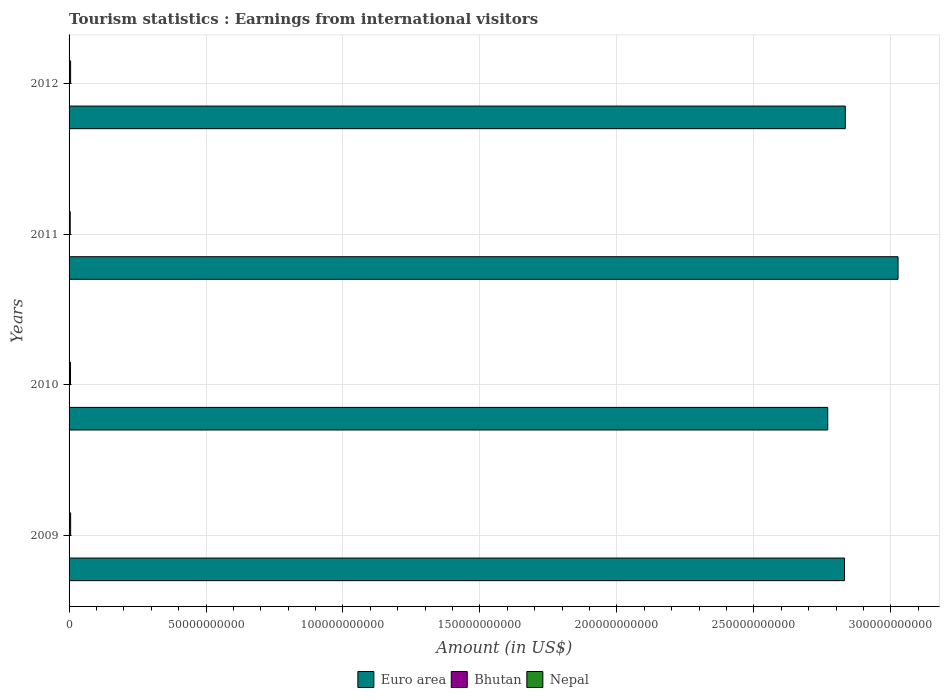How many groups of bars are there?
Keep it short and to the point. 4. Are the number of bars per tick equal to the number of legend labels?
Keep it short and to the point. Yes. Are the number of bars on each tick of the Y-axis equal?
Make the answer very short. Yes. How many bars are there on the 1st tick from the top?
Offer a very short reply. 3. How many bars are there on the 4th tick from the bottom?
Your answer should be compact. 3. What is the label of the 4th group of bars from the top?
Ensure brevity in your answer.  2009. What is the earnings from international visitors in Nepal in 2011?
Your answer should be compact. 4.20e+08. Across all years, what is the maximum earnings from international visitors in Bhutan?
Your answer should be very brief. 7.00e+07. Across all years, what is the minimum earnings from international visitors in Nepal?
Make the answer very short. 4.20e+08. In which year was the earnings from international visitors in Nepal maximum?
Offer a terse response. 2009. What is the total earnings from international visitors in Bhutan in the graph?
Ensure brevity in your answer.  2.05e+08. What is the difference between the earnings from international visitors in Euro area in 2009 and that in 2011?
Your answer should be compact. -1.95e+1. What is the difference between the earnings from international visitors in Euro area in 2010 and the earnings from international visitors in Bhutan in 2012?
Offer a very short reply. 2.77e+11. What is the average earnings from international visitors in Euro area per year?
Ensure brevity in your answer.  2.87e+11. In the year 2009, what is the difference between the earnings from international visitors in Bhutan and earnings from international visitors in Euro area?
Give a very brief answer. -2.83e+11. In how many years, is the earnings from international visitors in Nepal greater than 30000000000 US$?
Your response must be concise. 0. What is the ratio of the earnings from international visitors in Nepal in 2010 to that in 2011?
Your answer should be very brief. 1.26. Is the difference between the earnings from international visitors in Bhutan in 2010 and 2011 greater than the difference between the earnings from international visitors in Euro area in 2010 and 2011?
Provide a short and direct response. Yes. What is the difference between the highest and the second highest earnings from international visitors in Euro area?
Your answer should be very brief. 1.93e+1. What is the difference between the highest and the lowest earnings from international visitors in Nepal?
Make the answer very short. 1.52e+08. In how many years, is the earnings from international visitors in Bhutan greater than the average earnings from international visitors in Bhutan taken over all years?
Provide a short and direct response. 2. Is the sum of the earnings from international visitors in Bhutan in 2009 and 2011 greater than the maximum earnings from international visitors in Euro area across all years?
Provide a short and direct response. No. What does the 3rd bar from the top in 2010 represents?
Give a very brief answer. Euro area. Are all the bars in the graph horizontal?
Provide a short and direct response. Yes. What is the difference between two consecutive major ticks on the X-axis?
Offer a very short reply. 5.00e+1. Does the graph contain any zero values?
Ensure brevity in your answer.  No. What is the title of the graph?
Provide a short and direct response. Tourism statistics : Earnings from international visitors. Does "Tonga" appear as one of the legend labels in the graph?
Offer a terse response. No. What is the label or title of the Y-axis?
Provide a succinct answer. Years. What is the Amount (in US$) of Euro area in 2009?
Your answer should be compact. 2.83e+11. What is the Amount (in US$) of Bhutan in 2009?
Your answer should be very brief. 3.40e+07. What is the Amount (in US$) of Nepal in 2009?
Give a very brief answer. 5.72e+08. What is the Amount (in US$) in Euro area in 2010?
Ensure brevity in your answer.  2.77e+11. What is the Amount (in US$) in Bhutan in 2010?
Make the answer very short. 4.30e+07. What is the Amount (in US$) of Nepal in 2010?
Offer a terse response. 5.28e+08. What is the Amount (in US$) in Euro area in 2011?
Provide a succinct answer. 3.03e+11. What is the Amount (in US$) of Bhutan in 2011?
Your response must be concise. 5.80e+07. What is the Amount (in US$) of Nepal in 2011?
Ensure brevity in your answer.  4.20e+08. What is the Amount (in US$) in Euro area in 2012?
Offer a terse response. 2.83e+11. What is the Amount (in US$) of Bhutan in 2012?
Keep it short and to the point. 7.00e+07. What is the Amount (in US$) of Nepal in 2012?
Your answer should be compact. 5.62e+08. Across all years, what is the maximum Amount (in US$) in Euro area?
Offer a terse response. 3.03e+11. Across all years, what is the maximum Amount (in US$) in Bhutan?
Give a very brief answer. 7.00e+07. Across all years, what is the maximum Amount (in US$) in Nepal?
Ensure brevity in your answer.  5.72e+08. Across all years, what is the minimum Amount (in US$) in Euro area?
Your response must be concise. 2.77e+11. Across all years, what is the minimum Amount (in US$) of Bhutan?
Your answer should be very brief. 3.40e+07. Across all years, what is the minimum Amount (in US$) of Nepal?
Your answer should be very brief. 4.20e+08. What is the total Amount (in US$) in Euro area in the graph?
Your answer should be compact. 1.15e+12. What is the total Amount (in US$) of Bhutan in the graph?
Your answer should be very brief. 2.05e+08. What is the total Amount (in US$) of Nepal in the graph?
Your answer should be compact. 2.08e+09. What is the difference between the Amount (in US$) of Euro area in 2009 and that in 2010?
Provide a succinct answer. 6.13e+09. What is the difference between the Amount (in US$) of Bhutan in 2009 and that in 2010?
Make the answer very short. -9.00e+06. What is the difference between the Amount (in US$) of Nepal in 2009 and that in 2010?
Ensure brevity in your answer.  4.40e+07. What is the difference between the Amount (in US$) in Euro area in 2009 and that in 2011?
Offer a terse response. -1.95e+1. What is the difference between the Amount (in US$) of Bhutan in 2009 and that in 2011?
Provide a short and direct response. -2.40e+07. What is the difference between the Amount (in US$) in Nepal in 2009 and that in 2011?
Provide a short and direct response. 1.52e+08. What is the difference between the Amount (in US$) of Euro area in 2009 and that in 2012?
Your response must be concise. -2.75e+08. What is the difference between the Amount (in US$) in Bhutan in 2009 and that in 2012?
Your answer should be very brief. -3.60e+07. What is the difference between the Amount (in US$) in Nepal in 2009 and that in 2012?
Provide a succinct answer. 1.00e+07. What is the difference between the Amount (in US$) in Euro area in 2010 and that in 2011?
Offer a terse response. -2.57e+1. What is the difference between the Amount (in US$) in Bhutan in 2010 and that in 2011?
Make the answer very short. -1.50e+07. What is the difference between the Amount (in US$) of Nepal in 2010 and that in 2011?
Offer a terse response. 1.08e+08. What is the difference between the Amount (in US$) of Euro area in 2010 and that in 2012?
Give a very brief answer. -6.41e+09. What is the difference between the Amount (in US$) of Bhutan in 2010 and that in 2012?
Give a very brief answer. -2.70e+07. What is the difference between the Amount (in US$) in Nepal in 2010 and that in 2012?
Ensure brevity in your answer.  -3.40e+07. What is the difference between the Amount (in US$) in Euro area in 2011 and that in 2012?
Your answer should be very brief. 1.93e+1. What is the difference between the Amount (in US$) of Bhutan in 2011 and that in 2012?
Keep it short and to the point. -1.20e+07. What is the difference between the Amount (in US$) in Nepal in 2011 and that in 2012?
Offer a terse response. -1.42e+08. What is the difference between the Amount (in US$) of Euro area in 2009 and the Amount (in US$) of Bhutan in 2010?
Offer a very short reply. 2.83e+11. What is the difference between the Amount (in US$) in Euro area in 2009 and the Amount (in US$) in Nepal in 2010?
Give a very brief answer. 2.83e+11. What is the difference between the Amount (in US$) in Bhutan in 2009 and the Amount (in US$) in Nepal in 2010?
Keep it short and to the point. -4.94e+08. What is the difference between the Amount (in US$) of Euro area in 2009 and the Amount (in US$) of Bhutan in 2011?
Make the answer very short. 2.83e+11. What is the difference between the Amount (in US$) in Euro area in 2009 and the Amount (in US$) in Nepal in 2011?
Your response must be concise. 2.83e+11. What is the difference between the Amount (in US$) of Bhutan in 2009 and the Amount (in US$) of Nepal in 2011?
Make the answer very short. -3.86e+08. What is the difference between the Amount (in US$) in Euro area in 2009 and the Amount (in US$) in Bhutan in 2012?
Your answer should be very brief. 2.83e+11. What is the difference between the Amount (in US$) of Euro area in 2009 and the Amount (in US$) of Nepal in 2012?
Provide a succinct answer. 2.83e+11. What is the difference between the Amount (in US$) in Bhutan in 2009 and the Amount (in US$) in Nepal in 2012?
Your response must be concise. -5.28e+08. What is the difference between the Amount (in US$) in Euro area in 2010 and the Amount (in US$) in Bhutan in 2011?
Make the answer very short. 2.77e+11. What is the difference between the Amount (in US$) in Euro area in 2010 and the Amount (in US$) in Nepal in 2011?
Provide a succinct answer. 2.77e+11. What is the difference between the Amount (in US$) in Bhutan in 2010 and the Amount (in US$) in Nepal in 2011?
Your response must be concise. -3.77e+08. What is the difference between the Amount (in US$) in Euro area in 2010 and the Amount (in US$) in Bhutan in 2012?
Your answer should be very brief. 2.77e+11. What is the difference between the Amount (in US$) in Euro area in 2010 and the Amount (in US$) in Nepal in 2012?
Make the answer very short. 2.76e+11. What is the difference between the Amount (in US$) of Bhutan in 2010 and the Amount (in US$) of Nepal in 2012?
Provide a succinct answer. -5.19e+08. What is the difference between the Amount (in US$) of Euro area in 2011 and the Amount (in US$) of Bhutan in 2012?
Make the answer very short. 3.03e+11. What is the difference between the Amount (in US$) in Euro area in 2011 and the Amount (in US$) in Nepal in 2012?
Offer a terse response. 3.02e+11. What is the difference between the Amount (in US$) of Bhutan in 2011 and the Amount (in US$) of Nepal in 2012?
Offer a terse response. -5.04e+08. What is the average Amount (in US$) in Euro area per year?
Ensure brevity in your answer.  2.87e+11. What is the average Amount (in US$) in Bhutan per year?
Provide a short and direct response. 5.12e+07. What is the average Amount (in US$) in Nepal per year?
Offer a terse response. 5.20e+08. In the year 2009, what is the difference between the Amount (in US$) of Euro area and Amount (in US$) of Bhutan?
Your answer should be very brief. 2.83e+11. In the year 2009, what is the difference between the Amount (in US$) of Euro area and Amount (in US$) of Nepal?
Offer a very short reply. 2.83e+11. In the year 2009, what is the difference between the Amount (in US$) of Bhutan and Amount (in US$) of Nepal?
Provide a succinct answer. -5.38e+08. In the year 2010, what is the difference between the Amount (in US$) in Euro area and Amount (in US$) in Bhutan?
Your answer should be compact. 2.77e+11. In the year 2010, what is the difference between the Amount (in US$) of Euro area and Amount (in US$) of Nepal?
Offer a terse response. 2.76e+11. In the year 2010, what is the difference between the Amount (in US$) of Bhutan and Amount (in US$) of Nepal?
Provide a short and direct response. -4.85e+08. In the year 2011, what is the difference between the Amount (in US$) in Euro area and Amount (in US$) in Bhutan?
Provide a succinct answer. 3.03e+11. In the year 2011, what is the difference between the Amount (in US$) in Euro area and Amount (in US$) in Nepal?
Offer a terse response. 3.02e+11. In the year 2011, what is the difference between the Amount (in US$) in Bhutan and Amount (in US$) in Nepal?
Offer a terse response. -3.62e+08. In the year 2012, what is the difference between the Amount (in US$) in Euro area and Amount (in US$) in Bhutan?
Your response must be concise. 2.83e+11. In the year 2012, what is the difference between the Amount (in US$) in Euro area and Amount (in US$) in Nepal?
Keep it short and to the point. 2.83e+11. In the year 2012, what is the difference between the Amount (in US$) of Bhutan and Amount (in US$) of Nepal?
Ensure brevity in your answer.  -4.92e+08. What is the ratio of the Amount (in US$) in Euro area in 2009 to that in 2010?
Offer a terse response. 1.02. What is the ratio of the Amount (in US$) of Bhutan in 2009 to that in 2010?
Your answer should be very brief. 0.79. What is the ratio of the Amount (in US$) in Euro area in 2009 to that in 2011?
Keep it short and to the point. 0.94. What is the ratio of the Amount (in US$) in Bhutan in 2009 to that in 2011?
Provide a succinct answer. 0.59. What is the ratio of the Amount (in US$) in Nepal in 2009 to that in 2011?
Provide a short and direct response. 1.36. What is the ratio of the Amount (in US$) in Euro area in 2009 to that in 2012?
Provide a succinct answer. 1. What is the ratio of the Amount (in US$) in Bhutan in 2009 to that in 2012?
Your answer should be very brief. 0.49. What is the ratio of the Amount (in US$) of Nepal in 2009 to that in 2012?
Your answer should be very brief. 1.02. What is the ratio of the Amount (in US$) in Euro area in 2010 to that in 2011?
Give a very brief answer. 0.92. What is the ratio of the Amount (in US$) in Bhutan in 2010 to that in 2011?
Your response must be concise. 0.74. What is the ratio of the Amount (in US$) in Nepal in 2010 to that in 2011?
Provide a short and direct response. 1.26. What is the ratio of the Amount (in US$) in Euro area in 2010 to that in 2012?
Your answer should be very brief. 0.98. What is the ratio of the Amount (in US$) of Bhutan in 2010 to that in 2012?
Keep it short and to the point. 0.61. What is the ratio of the Amount (in US$) in Nepal in 2010 to that in 2012?
Keep it short and to the point. 0.94. What is the ratio of the Amount (in US$) of Euro area in 2011 to that in 2012?
Ensure brevity in your answer.  1.07. What is the ratio of the Amount (in US$) of Bhutan in 2011 to that in 2012?
Keep it short and to the point. 0.83. What is the ratio of the Amount (in US$) in Nepal in 2011 to that in 2012?
Your answer should be very brief. 0.75. What is the difference between the highest and the second highest Amount (in US$) in Euro area?
Your response must be concise. 1.93e+1. What is the difference between the highest and the second highest Amount (in US$) in Nepal?
Make the answer very short. 1.00e+07. What is the difference between the highest and the lowest Amount (in US$) in Euro area?
Ensure brevity in your answer.  2.57e+1. What is the difference between the highest and the lowest Amount (in US$) in Bhutan?
Your answer should be very brief. 3.60e+07. What is the difference between the highest and the lowest Amount (in US$) in Nepal?
Make the answer very short. 1.52e+08. 